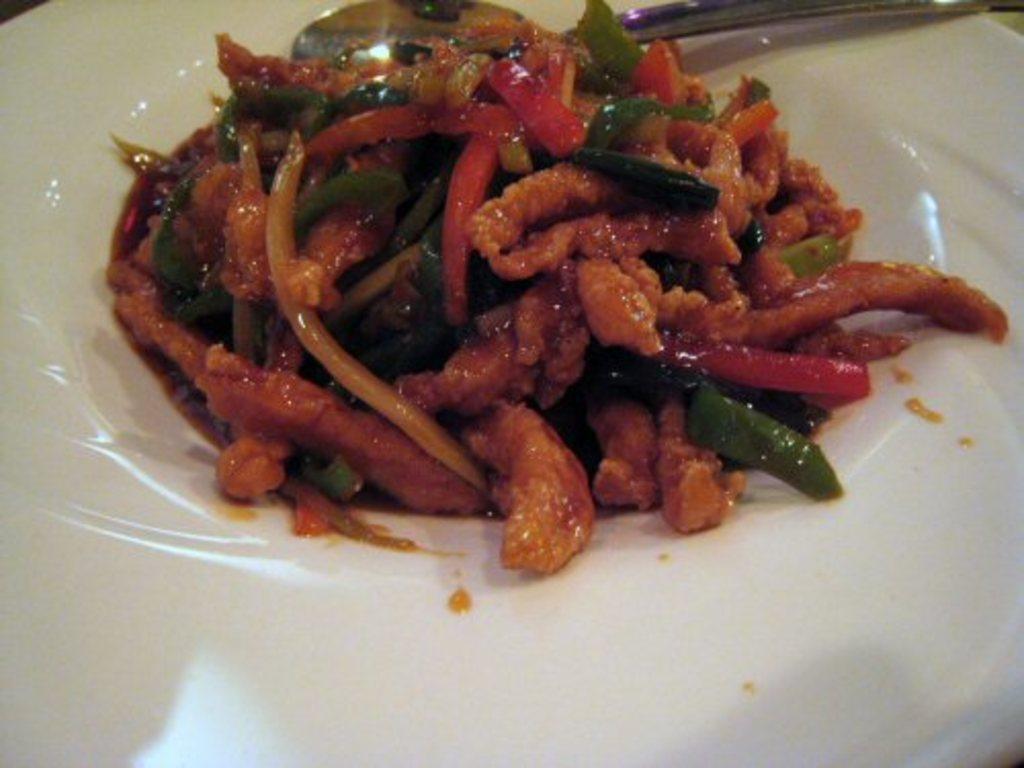Could you give a brief overview of what you see in this image? In this image there is a plate in that place there is a food and spoon. 